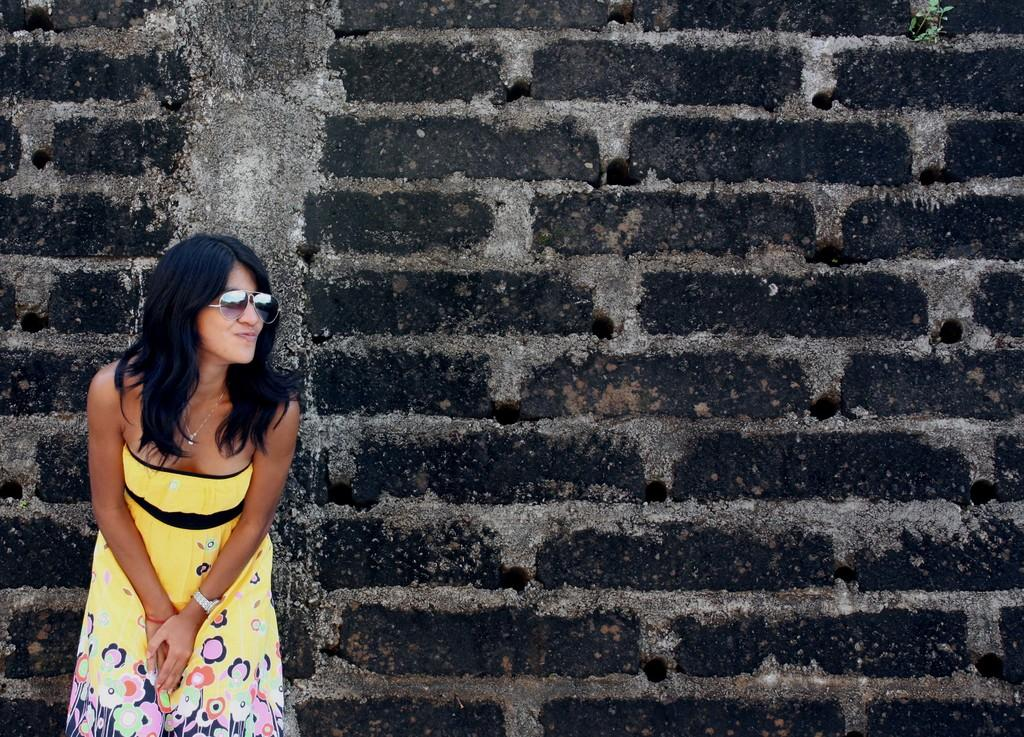What can be seen in the background of the image? There is a wall in the image. Where is the lady located in the image? The lady is standing on the left side of the image. What is the lady wearing in the image? The lady is wearing a yellow dress and goggles. How many children are playing with the tin in the image? There is no tin or children present in the image. What is the cause of the lady's death in the image? There is no indication of death in the image; the lady is standing and wearing goggles. 